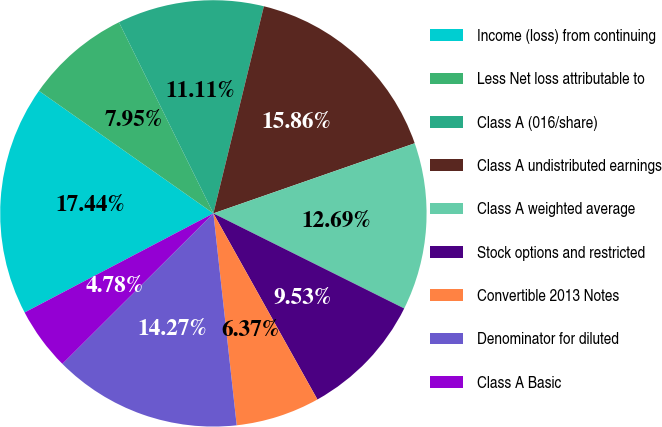<chart> <loc_0><loc_0><loc_500><loc_500><pie_chart><fcel>Income (loss) from continuing<fcel>Less Net loss attributable to<fcel>Class A (016/share)<fcel>Class A undistributed earnings<fcel>Class A weighted average<fcel>Stock options and restricted<fcel>Convertible 2013 Notes<fcel>Denominator for diluted<fcel>Class A Basic<nl><fcel>17.44%<fcel>7.95%<fcel>11.11%<fcel>15.86%<fcel>12.69%<fcel>9.53%<fcel>6.37%<fcel>14.27%<fcel>4.78%<nl></chart> 